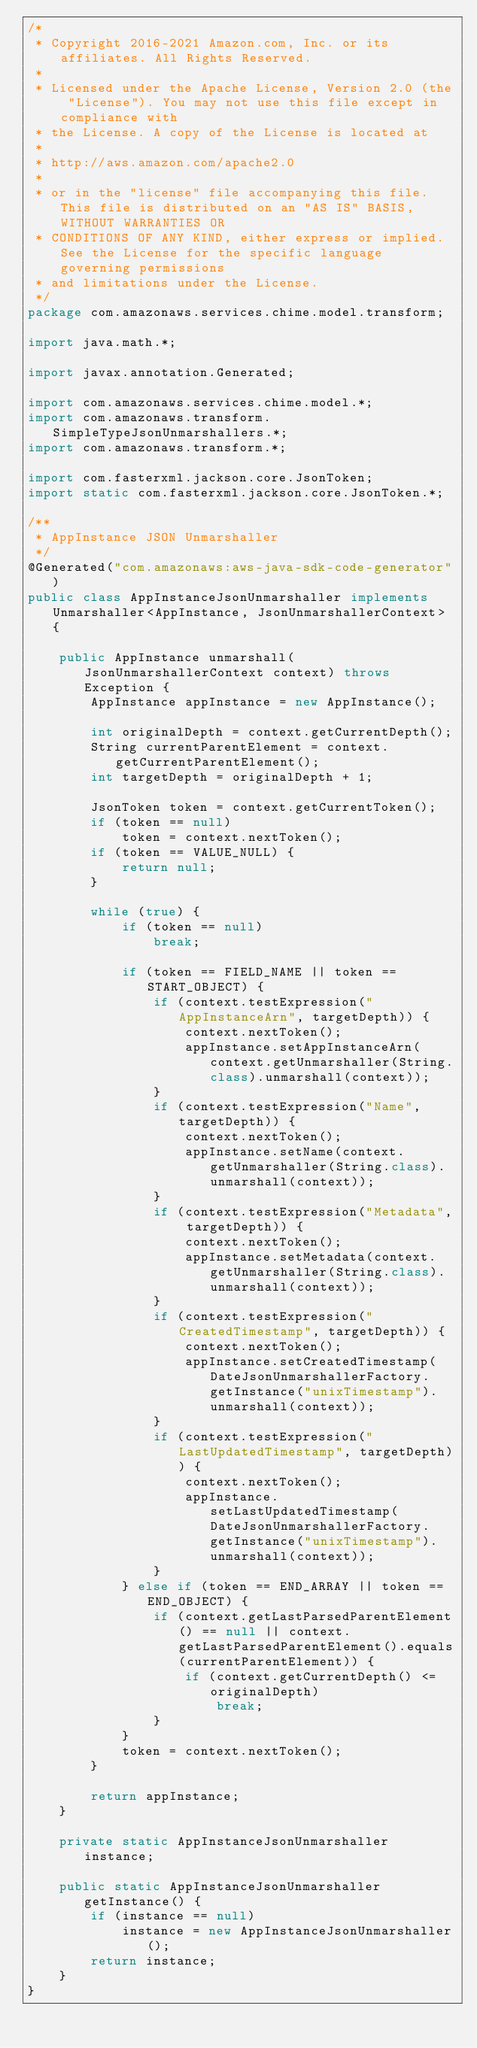Convert code to text. <code><loc_0><loc_0><loc_500><loc_500><_Java_>/*
 * Copyright 2016-2021 Amazon.com, Inc. or its affiliates. All Rights Reserved.
 * 
 * Licensed under the Apache License, Version 2.0 (the "License"). You may not use this file except in compliance with
 * the License. A copy of the License is located at
 * 
 * http://aws.amazon.com/apache2.0
 * 
 * or in the "license" file accompanying this file. This file is distributed on an "AS IS" BASIS, WITHOUT WARRANTIES OR
 * CONDITIONS OF ANY KIND, either express or implied. See the License for the specific language governing permissions
 * and limitations under the License.
 */
package com.amazonaws.services.chime.model.transform;

import java.math.*;

import javax.annotation.Generated;

import com.amazonaws.services.chime.model.*;
import com.amazonaws.transform.SimpleTypeJsonUnmarshallers.*;
import com.amazonaws.transform.*;

import com.fasterxml.jackson.core.JsonToken;
import static com.fasterxml.jackson.core.JsonToken.*;

/**
 * AppInstance JSON Unmarshaller
 */
@Generated("com.amazonaws:aws-java-sdk-code-generator")
public class AppInstanceJsonUnmarshaller implements Unmarshaller<AppInstance, JsonUnmarshallerContext> {

    public AppInstance unmarshall(JsonUnmarshallerContext context) throws Exception {
        AppInstance appInstance = new AppInstance();

        int originalDepth = context.getCurrentDepth();
        String currentParentElement = context.getCurrentParentElement();
        int targetDepth = originalDepth + 1;

        JsonToken token = context.getCurrentToken();
        if (token == null)
            token = context.nextToken();
        if (token == VALUE_NULL) {
            return null;
        }

        while (true) {
            if (token == null)
                break;

            if (token == FIELD_NAME || token == START_OBJECT) {
                if (context.testExpression("AppInstanceArn", targetDepth)) {
                    context.nextToken();
                    appInstance.setAppInstanceArn(context.getUnmarshaller(String.class).unmarshall(context));
                }
                if (context.testExpression("Name", targetDepth)) {
                    context.nextToken();
                    appInstance.setName(context.getUnmarshaller(String.class).unmarshall(context));
                }
                if (context.testExpression("Metadata", targetDepth)) {
                    context.nextToken();
                    appInstance.setMetadata(context.getUnmarshaller(String.class).unmarshall(context));
                }
                if (context.testExpression("CreatedTimestamp", targetDepth)) {
                    context.nextToken();
                    appInstance.setCreatedTimestamp(DateJsonUnmarshallerFactory.getInstance("unixTimestamp").unmarshall(context));
                }
                if (context.testExpression("LastUpdatedTimestamp", targetDepth)) {
                    context.nextToken();
                    appInstance.setLastUpdatedTimestamp(DateJsonUnmarshallerFactory.getInstance("unixTimestamp").unmarshall(context));
                }
            } else if (token == END_ARRAY || token == END_OBJECT) {
                if (context.getLastParsedParentElement() == null || context.getLastParsedParentElement().equals(currentParentElement)) {
                    if (context.getCurrentDepth() <= originalDepth)
                        break;
                }
            }
            token = context.nextToken();
        }

        return appInstance;
    }

    private static AppInstanceJsonUnmarshaller instance;

    public static AppInstanceJsonUnmarshaller getInstance() {
        if (instance == null)
            instance = new AppInstanceJsonUnmarshaller();
        return instance;
    }
}
</code> 